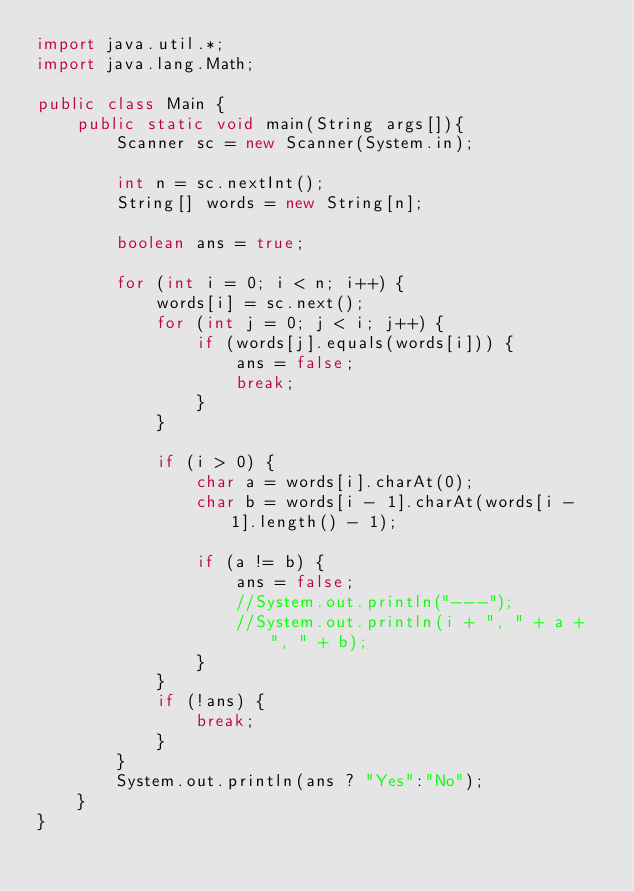<code> <loc_0><loc_0><loc_500><loc_500><_Java_>import java.util.*;
import java.lang.Math;

public class Main {
    public static void main(String args[]){
        Scanner sc = new Scanner(System.in);

        int n = sc.nextInt();
        String[] words = new String[n];

        boolean ans = true;

        for (int i = 0; i < n; i++) {
            words[i] = sc.next();
            for (int j = 0; j < i; j++) {
                if (words[j].equals(words[i])) {
                    ans = false;
                    break;
                }
            }

            if (i > 0) {
                char a = words[i].charAt(0);
                char b = words[i - 1].charAt(words[i - 1].length() - 1);

                if (a != b) {
                    ans = false;
                    //System.out.println("---");
                    //System.out.println(i + ", " + a + ", " + b);
                }
            }
            if (!ans) {
                break;
            }
        }
        System.out.println(ans ? "Yes":"No");
    }
}
</code> 